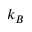Convert formula to latex. <formula><loc_0><loc_0><loc_500><loc_500>k _ { B }</formula> 